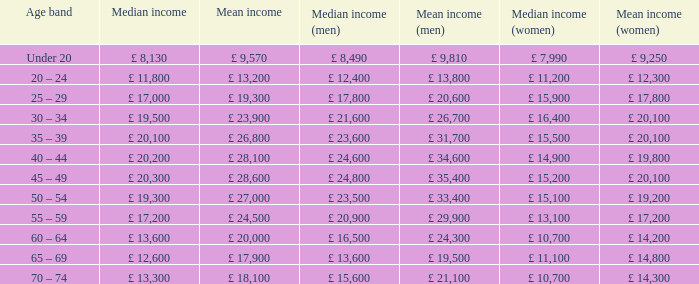State the central income for people in the age category of less than 20 years. £ 8,130. 